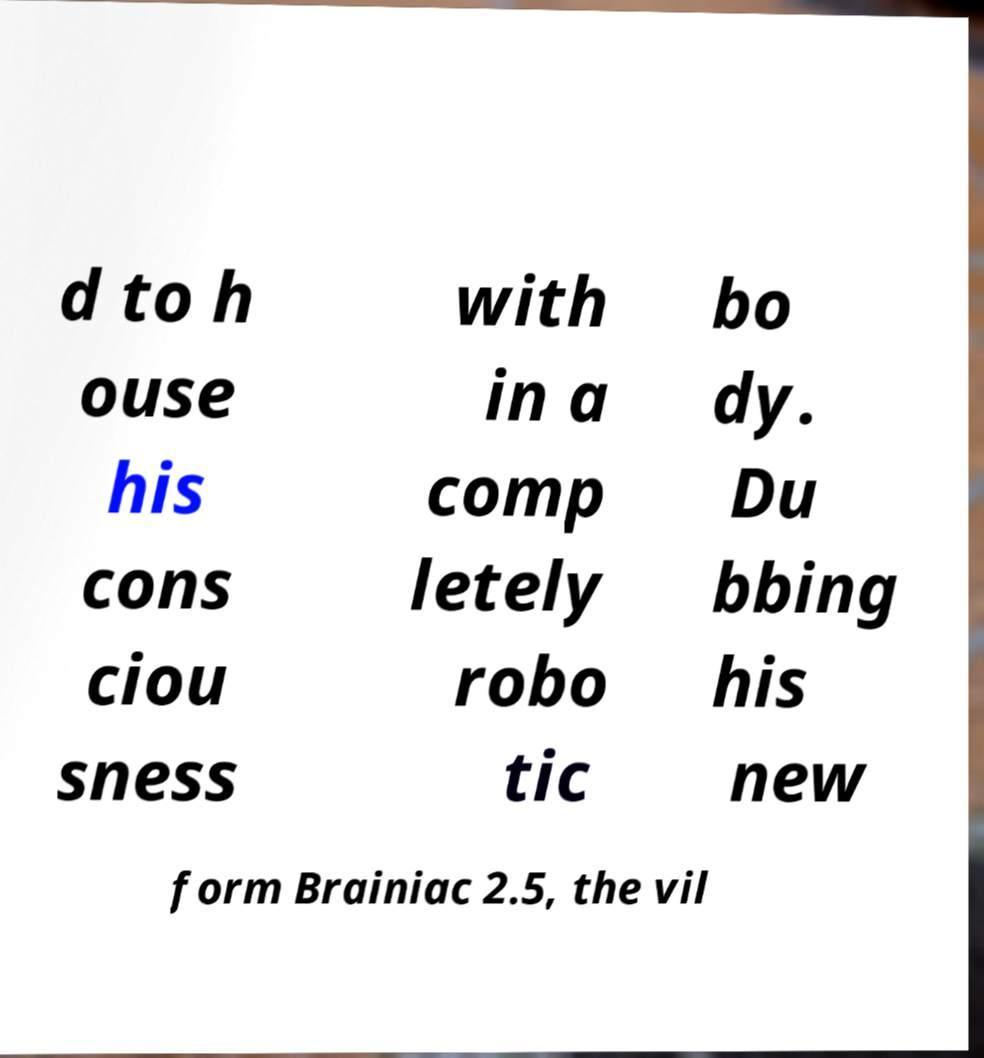Please identify and transcribe the text found in this image. d to h ouse his cons ciou sness with in a comp letely robo tic bo dy. Du bbing his new form Brainiac 2.5, the vil 